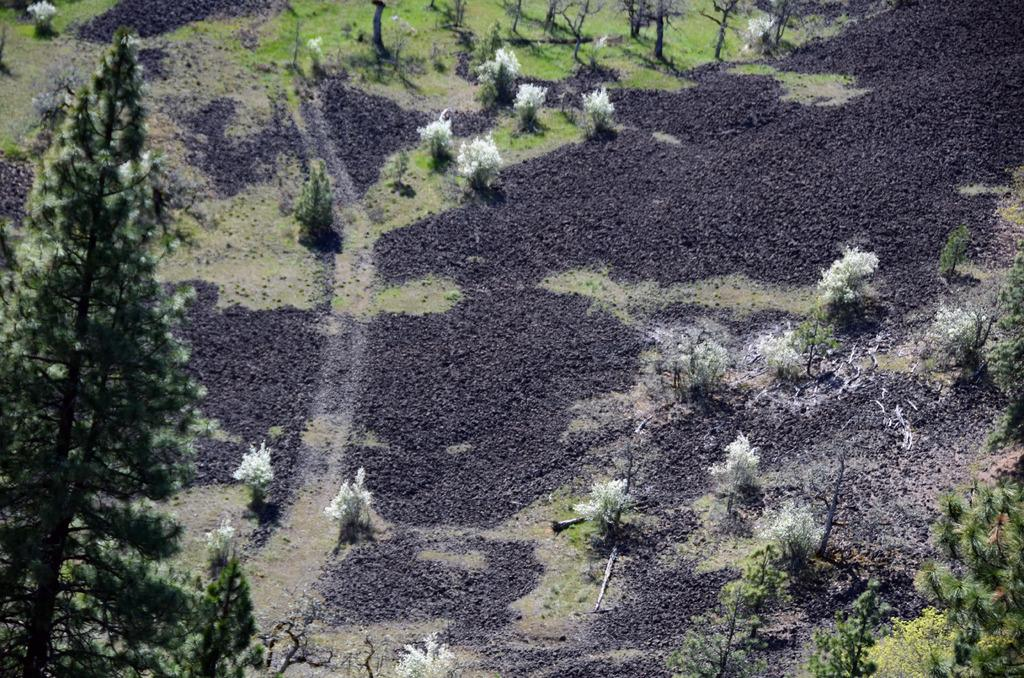What type of ground covering is visible in the image? The ground in the image is covered with grass. What type of pathway can be seen in the image? There is a road in the image. What type of vegetation is present in the image? There are plants and trees in the image. What type of bird can be seen nesting in the trees in the image? There are no birds visible in the image, so it is not possible to determine what type of bird might be nesting in the trees. 